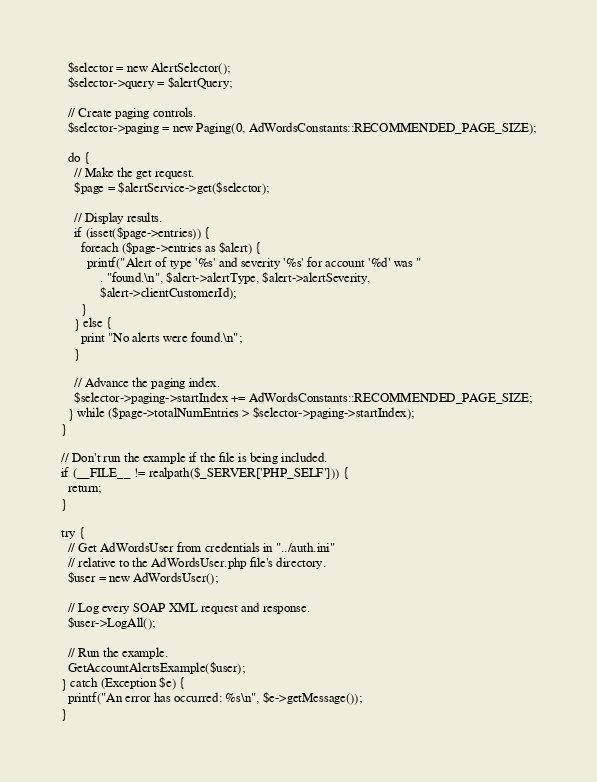<code> <loc_0><loc_0><loc_500><loc_500><_PHP_>  $selector = new AlertSelector();
  $selector->query = $alertQuery;

  // Create paging controls.
  $selector->paging = new Paging(0, AdWordsConstants::RECOMMENDED_PAGE_SIZE);

  do {
    // Make the get request.
    $page = $alertService->get($selector);

    // Display results.
    if (isset($page->entries)) {
      foreach ($page->entries as $alert) {
        printf("Alert of type '%s' and severity '%s' for account '%d' was "
            . "found.\n", $alert->alertType, $alert->alertSeverity,
            $alert->clientCustomerId);
      }
    } else {
      print "No alerts were found.\n";
    }

    // Advance the paging index.
    $selector->paging->startIndex += AdWordsConstants::RECOMMENDED_PAGE_SIZE;
  } while ($page->totalNumEntries > $selector->paging->startIndex);
}

// Don't run the example if the file is being included.
if (__FILE__ != realpath($_SERVER['PHP_SELF'])) {
  return;
}

try {
  // Get AdWordsUser from credentials in "../auth.ini"
  // relative to the AdWordsUser.php file's directory.
  $user = new AdWordsUser();

  // Log every SOAP XML request and response.
  $user->LogAll();

  // Run the example.
  GetAccountAlertsExample($user);
} catch (Exception $e) {
  printf("An error has occurred: %s\n", $e->getMessage());
}
</code> 